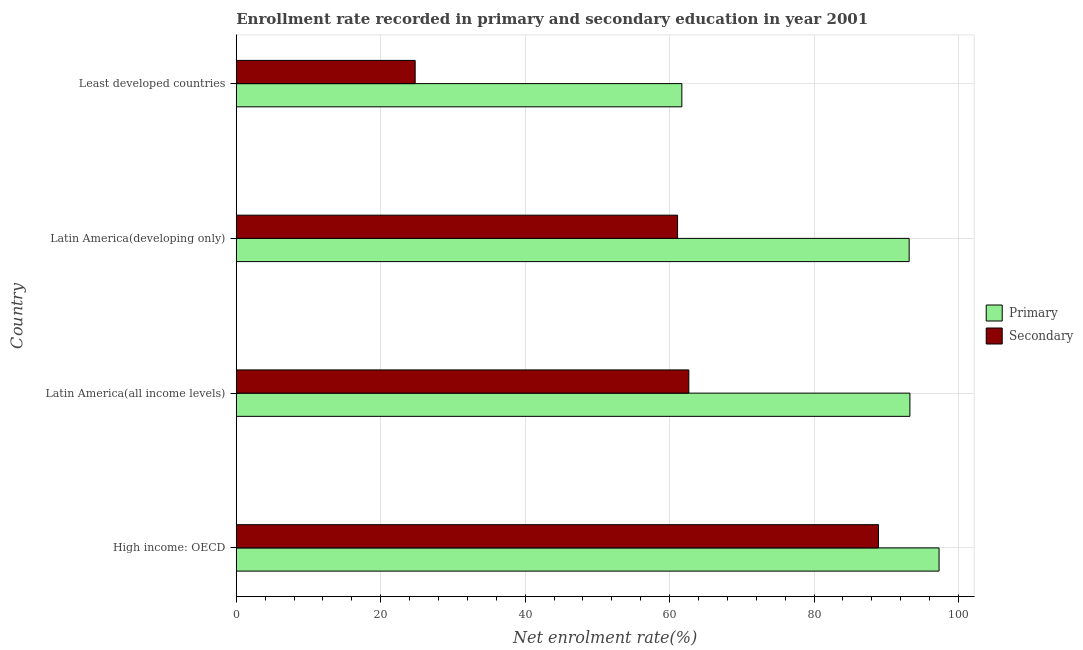How many different coloured bars are there?
Keep it short and to the point. 2. How many groups of bars are there?
Provide a short and direct response. 4. Are the number of bars on each tick of the Y-axis equal?
Your answer should be compact. Yes. How many bars are there on the 2nd tick from the top?
Your response must be concise. 2. What is the label of the 1st group of bars from the top?
Ensure brevity in your answer.  Least developed countries. What is the enrollment rate in primary education in Least developed countries?
Provide a short and direct response. 61.7. Across all countries, what is the maximum enrollment rate in primary education?
Your response must be concise. 97.31. Across all countries, what is the minimum enrollment rate in secondary education?
Ensure brevity in your answer.  24.77. In which country was the enrollment rate in secondary education maximum?
Offer a terse response. High income: OECD. In which country was the enrollment rate in primary education minimum?
Offer a terse response. Least developed countries. What is the total enrollment rate in primary education in the graph?
Your answer should be compact. 345.46. What is the difference between the enrollment rate in primary education in Latin America(developing only) and that in Least developed countries?
Your answer should be compact. 31.47. What is the difference between the enrollment rate in primary education in Least developed countries and the enrollment rate in secondary education in Latin America(all income levels)?
Offer a very short reply. -0.97. What is the average enrollment rate in secondary education per country?
Your answer should be compact. 59.37. What is the difference between the enrollment rate in secondary education and enrollment rate in primary education in Least developed countries?
Keep it short and to the point. -36.92. What is the ratio of the enrollment rate in secondary education in High income: OECD to that in Least developed countries?
Offer a very short reply. 3.59. Is the enrollment rate in secondary education in Latin America(developing only) less than that in Least developed countries?
Offer a terse response. No. What is the difference between the highest and the second highest enrollment rate in primary education?
Offer a terse response. 4.04. What is the difference between the highest and the lowest enrollment rate in primary education?
Make the answer very short. 35.62. What does the 1st bar from the top in High income: OECD represents?
Provide a succinct answer. Secondary. What does the 2nd bar from the bottom in Latin America(all income levels) represents?
Provide a short and direct response. Secondary. What is the difference between two consecutive major ticks on the X-axis?
Ensure brevity in your answer.  20. Are the values on the major ticks of X-axis written in scientific E-notation?
Keep it short and to the point. No. Where does the legend appear in the graph?
Your response must be concise. Center right. How many legend labels are there?
Give a very brief answer. 2. What is the title of the graph?
Offer a very short reply. Enrollment rate recorded in primary and secondary education in year 2001. What is the label or title of the X-axis?
Keep it short and to the point. Net enrolment rate(%). What is the label or title of the Y-axis?
Your answer should be very brief. Country. What is the Net enrolment rate(%) in Primary in High income: OECD?
Offer a very short reply. 97.31. What is the Net enrolment rate(%) of Secondary in High income: OECD?
Keep it short and to the point. 88.93. What is the Net enrolment rate(%) of Primary in Latin America(all income levels)?
Provide a short and direct response. 93.28. What is the Net enrolment rate(%) of Secondary in Latin America(all income levels)?
Ensure brevity in your answer.  62.67. What is the Net enrolment rate(%) of Primary in Latin America(developing only)?
Your answer should be compact. 93.17. What is the Net enrolment rate(%) of Secondary in Latin America(developing only)?
Provide a short and direct response. 61.11. What is the Net enrolment rate(%) in Primary in Least developed countries?
Give a very brief answer. 61.7. What is the Net enrolment rate(%) in Secondary in Least developed countries?
Keep it short and to the point. 24.77. Across all countries, what is the maximum Net enrolment rate(%) in Primary?
Give a very brief answer. 97.31. Across all countries, what is the maximum Net enrolment rate(%) of Secondary?
Ensure brevity in your answer.  88.93. Across all countries, what is the minimum Net enrolment rate(%) of Primary?
Provide a short and direct response. 61.7. Across all countries, what is the minimum Net enrolment rate(%) in Secondary?
Provide a short and direct response. 24.77. What is the total Net enrolment rate(%) in Primary in the graph?
Your answer should be compact. 345.46. What is the total Net enrolment rate(%) in Secondary in the graph?
Provide a succinct answer. 237.47. What is the difference between the Net enrolment rate(%) in Primary in High income: OECD and that in Latin America(all income levels)?
Give a very brief answer. 4.04. What is the difference between the Net enrolment rate(%) of Secondary in High income: OECD and that in Latin America(all income levels)?
Ensure brevity in your answer.  26.26. What is the difference between the Net enrolment rate(%) of Primary in High income: OECD and that in Latin America(developing only)?
Make the answer very short. 4.14. What is the difference between the Net enrolment rate(%) in Secondary in High income: OECD and that in Latin America(developing only)?
Your response must be concise. 27.82. What is the difference between the Net enrolment rate(%) of Primary in High income: OECD and that in Least developed countries?
Offer a very short reply. 35.62. What is the difference between the Net enrolment rate(%) in Secondary in High income: OECD and that in Least developed countries?
Make the answer very short. 64.15. What is the difference between the Net enrolment rate(%) of Primary in Latin America(all income levels) and that in Latin America(developing only)?
Provide a short and direct response. 0.11. What is the difference between the Net enrolment rate(%) in Secondary in Latin America(all income levels) and that in Latin America(developing only)?
Provide a short and direct response. 1.56. What is the difference between the Net enrolment rate(%) of Primary in Latin America(all income levels) and that in Least developed countries?
Offer a terse response. 31.58. What is the difference between the Net enrolment rate(%) of Secondary in Latin America(all income levels) and that in Least developed countries?
Offer a terse response. 37.89. What is the difference between the Net enrolment rate(%) of Primary in Latin America(developing only) and that in Least developed countries?
Offer a terse response. 31.47. What is the difference between the Net enrolment rate(%) in Secondary in Latin America(developing only) and that in Least developed countries?
Provide a short and direct response. 36.33. What is the difference between the Net enrolment rate(%) of Primary in High income: OECD and the Net enrolment rate(%) of Secondary in Latin America(all income levels)?
Offer a terse response. 34.65. What is the difference between the Net enrolment rate(%) of Primary in High income: OECD and the Net enrolment rate(%) of Secondary in Latin America(developing only)?
Make the answer very short. 36.21. What is the difference between the Net enrolment rate(%) in Primary in High income: OECD and the Net enrolment rate(%) in Secondary in Least developed countries?
Your response must be concise. 72.54. What is the difference between the Net enrolment rate(%) of Primary in Latin America(all income levels) and the Net enrolment rate(%) of Secondary in Latin America(developing only)?
Keep it short and to the point. 32.17. What is the difference between the Net enrolment rate(%) in Primary in Latin America(all income levels) and the Net enrolment rate(%) in Secondary in Least developed countries?
Give a very brief answer. 68.5. What is the difference between the Net enrolment rate(%) in Primary in Latin America(developing only) and the Net enrolment rate(%) in Secondary in Least developed countries?
Your answer should be very brief. 68.4. What is the average Net enrolment rate(%) in Primary per country?
Offer a very short reply. 86.36. What is the average Net enrolment rate(%) in Secondary per country?
Provide a succinct answer. 59.37. What is the difference between the Net enrolment rate(%) of Primary and Net enrolment rate(%) of Secondary in High income: OECD?
Provide a short and direct response. 8.39. What is the difference between the Net enrolment rate(%) in Primary and Net enrolment rate(%) in Secondary in Latin America(all income levels)?
Give a very brief answer. 30.61. What is the difference between the Net enrolment rate(%) of Primary and Net enrolment rate(%) of Secondary in Latin America(developing only)?
Provide a short and direct response. 32.06. What is the difference between the Net enrolment rate(%) in Primary and Net enrolment rate(%) in Secondary in Least developed countries?
Keep it short and to the point. 36.92. What is the ratio of the Net enrolment rate(%) of Primary in High income: OECD to that in Latin America(all income levels)?
Give a very brief answer. 1.04. What is the ratio of the Net enrolment rate(%) in Secondary in High income: OECD to that in Latin America(all income levels)?
Your answer should be very brief. 1.42. What is the ratio of the Net enrolment rate(%) in Primary in High income: OECD to that in Latin America(developing only)?
Give a very brief answer. 1.04. What is the ratio of the Net enrolment rate(%) of Secondary in High income: OECD to that in Latin America(developing only)?
Offer a terse response. 1.46. What is the ratio of the Net enrolment rate(%) of Primary in High income: OECD to that in Least developed countries?
Make the answer very short. 1.58. What is the ratio of the Net enrolment rate(%) of Secondary in High income: OECD to that in Least developed countries?
Your answer should be compact. 3.59. What is the ratio of the Net enrolment rate(%) of Secondary in Latin America(all income levels) to that in Latin America(developing only)?
Your answer should be compact. 1.03. What is the ratio of the Net enrolment rate(%) in Primary in Latin America(all income levels) to that in Least developed countries?
Your answer should be compact. 1.51. What is the ratio of the Net enrolment rate(%) of Secondary in Latin America(all income levels) to that in Least developed countries?
Provide a short and direct response. 2.53. What is the ratio of the Net enrolment rate(%) in Primary in Latin America(developing only) to that in Least developed countries?
Make the answer very short. 1.51. What is the ratio of the Net enrolment rate(%) in Secondary in Latin America(developing only) to that in Least developed countries?
Keep it short and to the point. 2.47. What is the difference between the highest and the second highest Net enrolment rate(%) in Primary?
Offer a very short reply. 4.04. What is the difference between the highest and the second highest Net enrolment rate(%) of Secondary?
Provide a short and direct response. 26.26. What is the difference between the highest and the lowest Net enrolment rate(%) of Primary?
Your answer should be very brief. 35.62. What is the difference between the highest and the lowest Net enrolment rate(%) of Secondary?
Provide a short and direct response. 64.15. 